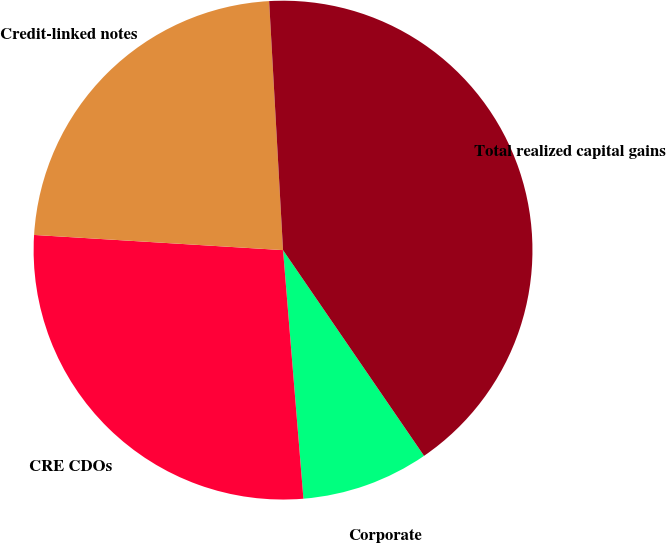Convert chart to OTSL. <chart><loc_0><loc_0><loc_500><loc_500><pie_chart><fcel>Corporate<fcel>CRE CDOs<fcel>Credit-linked notes<fcel>Total realized capital gains<nl><fcel>8.26%<fcel>27.27%<fcel>23.14%<fcel>41.32%<nl></chart> 